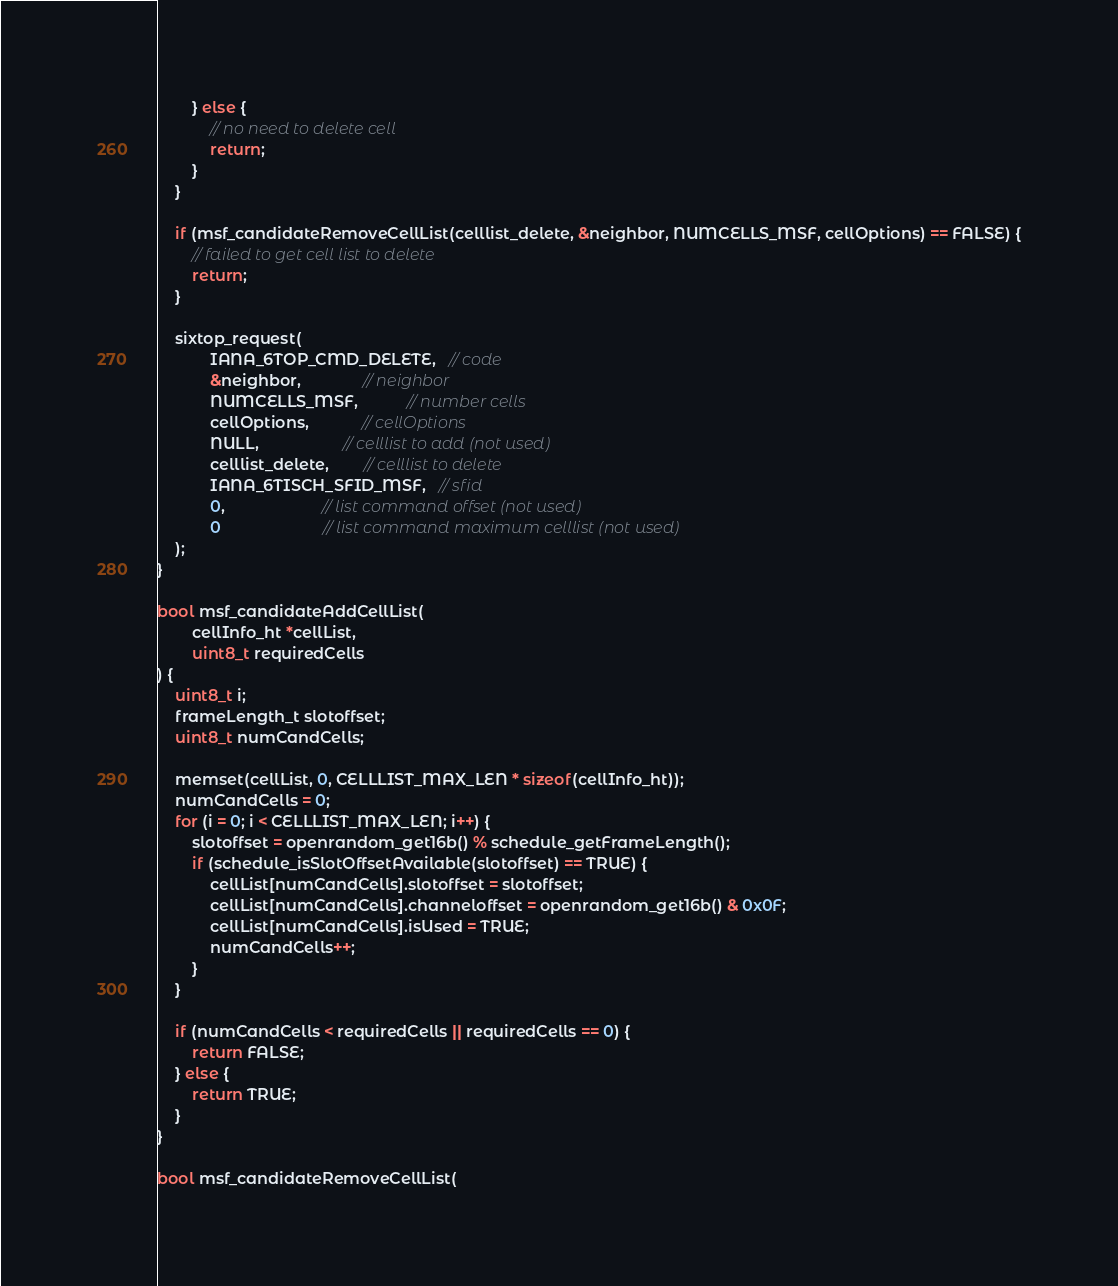<code> <loc_0><loc_0><loc_500><loc_500><_C_>        } else {
            // no need to delete cell
            return;
        }
    }

    if (msf_candidateRemoveCellList(celllist_delete, &neighbor, NUMCELLS_MSF, cellOptions) == FALSE) {
        // failed to get cell list to delete
        return;
    }

    sixtop_request(
            IANA_6TOP_CMD_DELETE,   // code
            &neighbor,              // neighbor
            NUMCELLS_MSF,           // number cells
            cellOptions,            // cellOptions
            NULL,                   // celllist to add (not used)
            celllist_delete,        // celllist to delete
            IANA_6TISCH_SFID_MSF,   // sfid
            0,                      // list command offset (not used)
            0                       // list command maximum celllist (not used)
    );
}

bool msf_candidateAddCellList(
        cellInfo_ht *cellList,
        uint8_t requiredCells
) {
    uint8_t i;
    frameLength_t slotoffset;
    uint8_t numCandCells;

    memset(cellList, 0, CELLLIST_MAX_LEN * sizeof(cellInfo_ht));
    numCandCells = 0;
    for (i = 0; i < CELLLIST_MAX_LEN; i++) {
        slotoffset = openrandom_get16b() % schedule_getFrameLength();
        if (schedule_isSlotOffsetAvailable(slotoffset) == TRUE) {
            cellList[numCandCells].slotoffset = slotoffset;
            cellList[numCandCells].channeloffset = openrandom_get16b() & 0x0F;
            cellList[numCandCells].isUsed = TRUE;
            numCandCells++;
        }
    }

    if (numCandCells < requiredCells || requiredCells == 0) {
        return FALSE;
    } else {
        return TRUE;
    }
}

bool msf_candidateRemoveCellList(</code> 